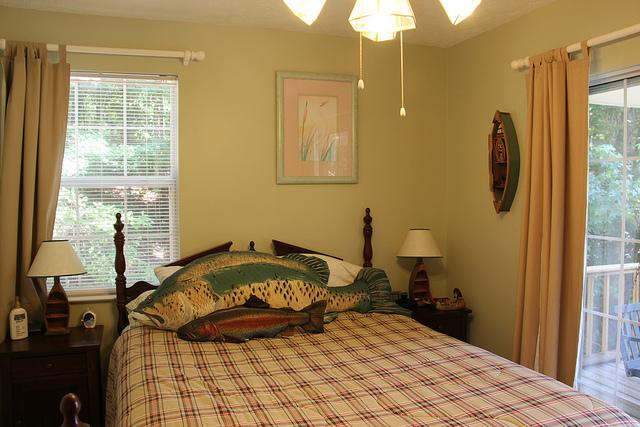What type of food is the animal on the bed classified as? fish 